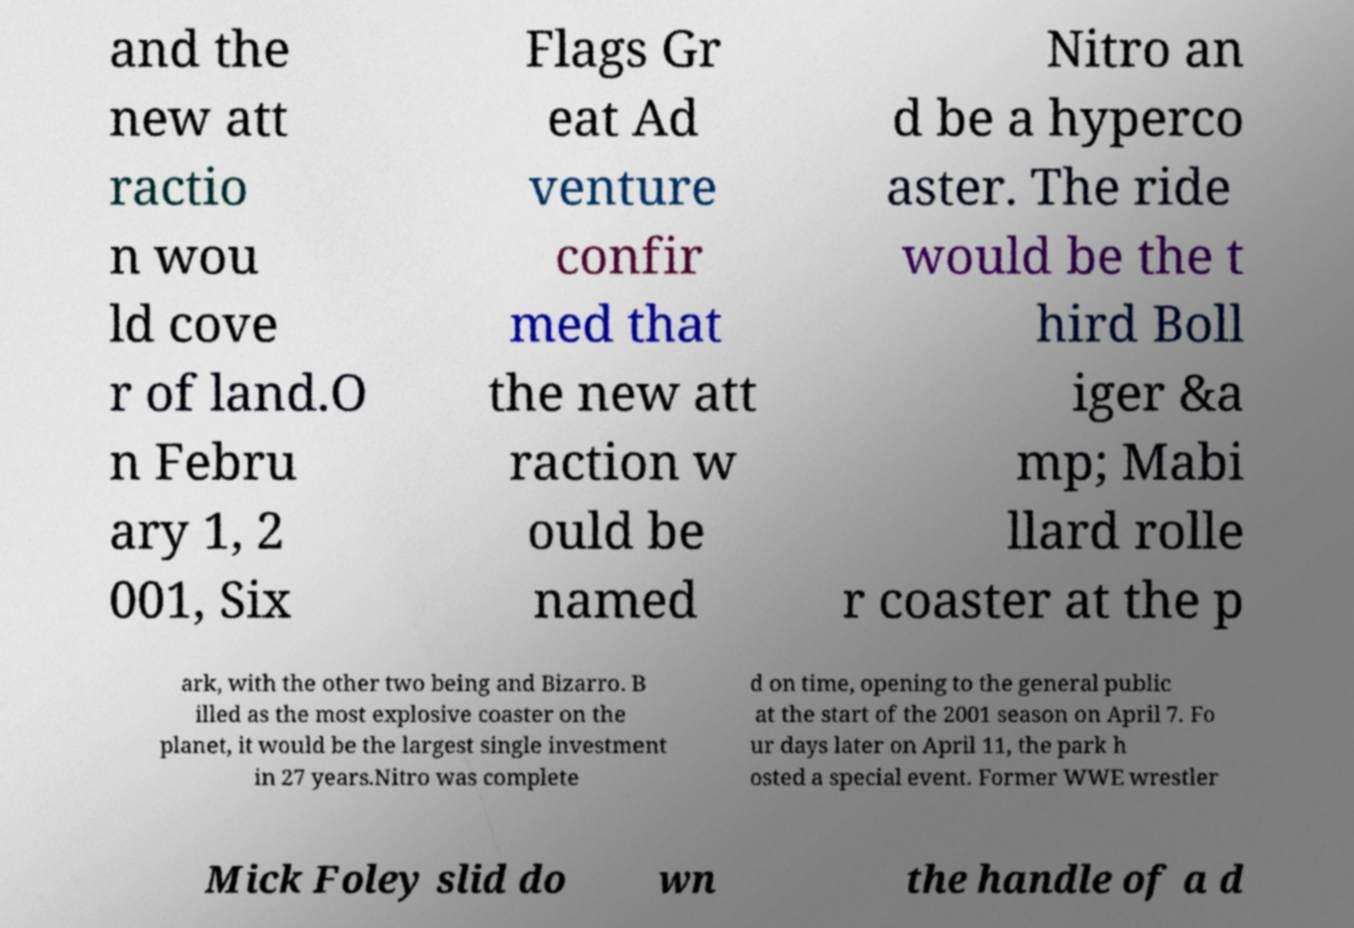For documentation purposes, I need the text within this image transcribed. Could you provide that? and the new att ractio n wou ld cove r of land.O n Febru ary 1, 2 001, Six Flags Gr eat Ad venture confir med that the new att raction w ould be named Nitro an d be a hyperco aster. The ride would be the t hird Boll iger &a mp; Mabi llard rolle r coaster at the p ark, with the other two being and Bizarro. B illed as the most explosive coaster on the planet, it would be the largest single investment in 27 years.Nitro was complete d on time, opening to the general public at the start of the 2001 season on April 7. Fo ur days later on April 11, the park h osted a special event. Former WWE wrestler Mick Foley slid do wn the handle of a d 